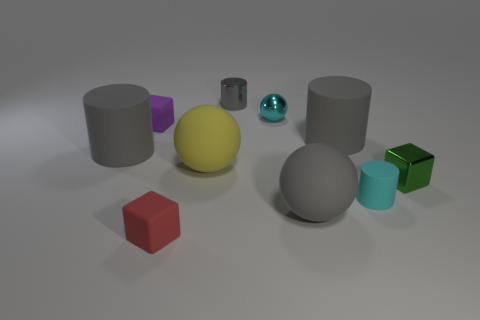Subtract all brown balls. How many gray cylinders are left? 3 Subtract 1 cylinders. How many cylinders are left? 3 Subtract all blocks. How many objects are left? 7 Add 6 tiny cyan shiny things. How many tiny cyan shiny things are left? 7 Add 6 tiny purple cubes. How many tiny purple cubes exist? 7 Subtract 1 green cubes. How many objects are left? 9 Subtract all rubber things. Subtract all brown metallic blocks. How many objects are left? 3 